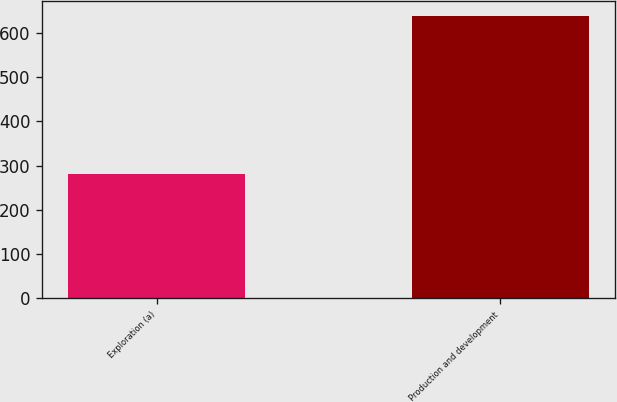Convert chart. <chart><loc_0><loc_0><loc_500><loc_500><bar_chart><fcel>Exploration (a)<fcel>Production and development<nl><fcel>280<fcel>639<nl></chart> 